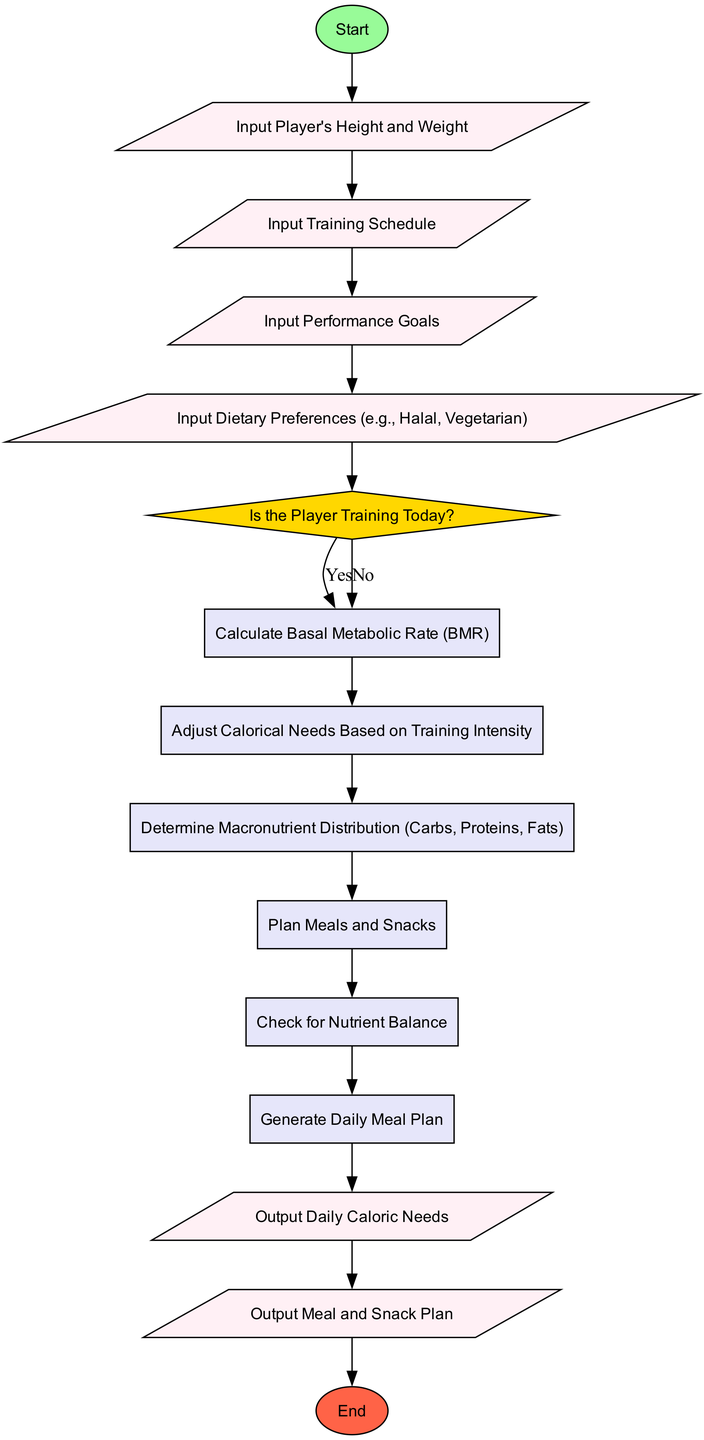What is the first input in the diagram? The diagram starts with the node labeled "Input Player's Height and Weight," which is the initial input processed.
Answer: Input Player's Height and Weight How many decision nodes are present in the diagram? There is one decision node in the diagram, asking "Is the Player Training Today?" which directs the flow based on the answer.
Answer: 1 What are the outputs of this diagram? The diagram has two output nodes: "Output Daily Caloric Needs" and "Output Meal and Snack Plan." These nodes represent the final results of the process.
Answer: Output Daily Caloric Needs, Output Meal and Snack Plan What happens if the answer to "Is the Player Training Today?" is 'No'? If the answer is 'No', the process continues to calculate Rest Day Caloric Needs as the next step, and then proceeds through the subsequent processes.
Answer: Calculate Rest Day Caloric Needs List the types of dietary preferences that can be inputted. The dietary preferences inputted can include options like Halal and Vegetarian, as stated in the input sections of the flowchart.
Answer: Halal, Vegetarian What is the purpose of calculating the Basal Metabolic Rate (BMR)? The purpose of calculating BMR is to establish a baseline for the player's caloric needs before making adjustments for activity levels or dietary preferences.
Answer: Establish baseline caloric needs How many process nodes are in the flowchart? There are six process nodes in the diagram, detailing different stages of the nutritional planning process after the decision point.
Answer: 6 What edge connects from the last input node to the decision node? The edge that connects the last input node, which is "Input Dietary Preferences," to the decision node leads to the question "Is the Player Training Today?" indicating the next decision to be made.
Answer: Input Dietary Preferences to decision What type of shapes are used for input and output nodes in the diagram? Input nodes are represented as parallelograms, while output nodes are also in the same shape, which distinguishes them from process nodes shaped as rectangles.
Answer: Parallelograms for inputs and outputs 